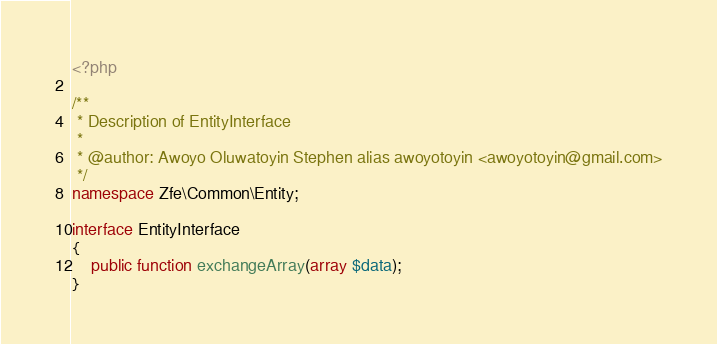<code> <loc_0><loc_0><loc_500><loc_500><_PHP_><?php

/**
 * Description of EntityInterface
 *
 * @author: Awoyo Oluwatoyin Stephen alias awoyotoyin <awoyotoyin@gmail.com>
 */
namespace Zfe\Common\Entity;

interface EntityInterface
{
    public function exchangeArray(array $data);
}
</code> 